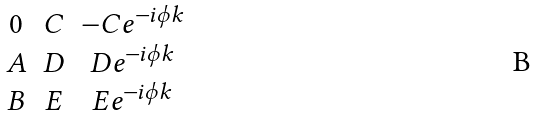Convert formula to latex. <formula><loc_0><loc_0><loc_500><loc_500>\begin{matrix} 0 & C & - C e ^ { - i \phi k } \\ A & D & D e ^ { - i \phi k } \\ B & E & E e ^ { - i \phi k } \end{matrix}</formula> 